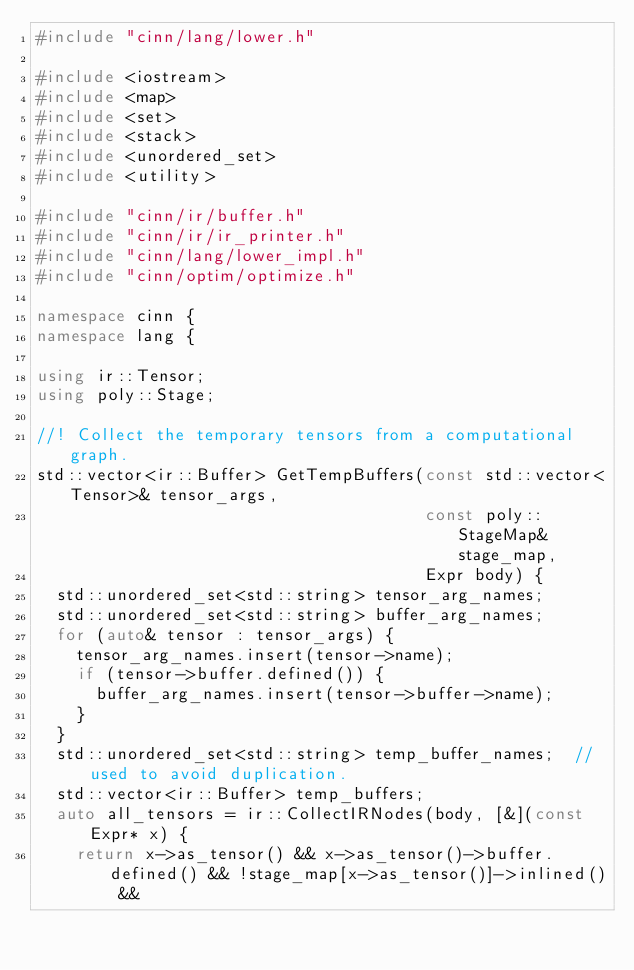<code> <loc_0><loc_0><loc_500><loc_500><_C++_>#include "cinn/lang/lower.h"

#include <iostream>
#include <map>
#include <set>
#include <stack>
#include <unordered_set>
#include <utility>

#include "cinn/ir/buffer.h"
#include "cinn/ir/ir_printer.h"
#include "cinn/lang/lower_impl.h"
#include "cinn/optim/optimize.h"

namespace cinn {
namespace lang {

using ir::Tensor;
using poly::Stage;

//! Collect the temporary tensors from a computational graph.
std::vector<ir::Buffer> GetTempBuffers(const std::vector<Tensor>& tensor_args,
                                       const poly::StageMap& stage_map,
                                       Expr body) {
  std::unordered_set<std::string> tensor_arg_names;
  std::unordered_set<std::string> buffer_arg_names;
  for (auto& tensor : tensor_args) {
    tensor_arg_names.insert(tensor->name);
    if (tensor->buffer.defined()) {
      buffer_arg_names.insert(tensor->buffer->name);
    }
  }
  std::unordered_set<std::string> temp_buffer_names;  // used to avoid duplication.
  std::vector<ir::Buffer> temp_buffers;
  auto all_tensors = ir::CollectIRNodes(body, [&](const Expr* x) {
    return x->as_tensor() && x->as_tensor()->buffer.defined() && !stage_map[x->as_tensor()]->inlined() &&</code> 